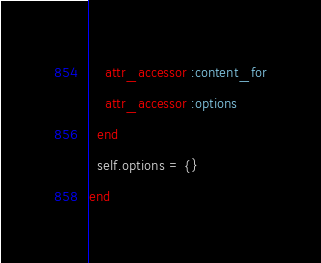<code> <loc_0><loc_0><loc_500><loc_500><_Ruby_>    attr_accessor :content_for
    attr_accessor :options
  end
  self.options = {}
end
</code> 